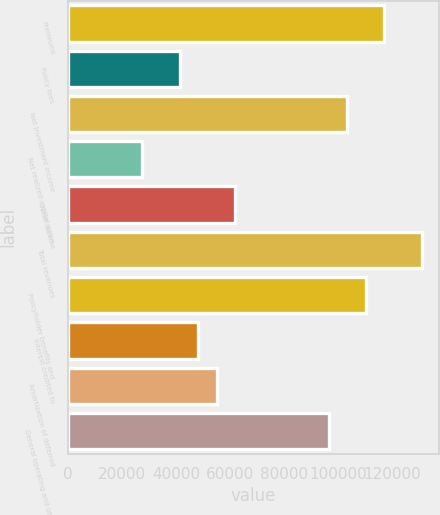<chart> <loc_0><loc_0><loc_500><loc_500><bar_chart><fcel>Premiums<fcel>Policy fees<fcel>Net investment income<fcel>Net realized capital gains<fcel>Other income<fcel>Total revenues<fcel>Policyholder benefits and<fcel>Interest credited to<fcel>Amortization of deferred<fcel>General operating and other<nl><fcel>117081<fcel>41327.2<fcel>103308<fcel>27553.8<fcel>61987.3<fcel>130854<fcel>110194<fcel>48213.9<fcel>55100.6<fcel>96420.8<nl></chart> 